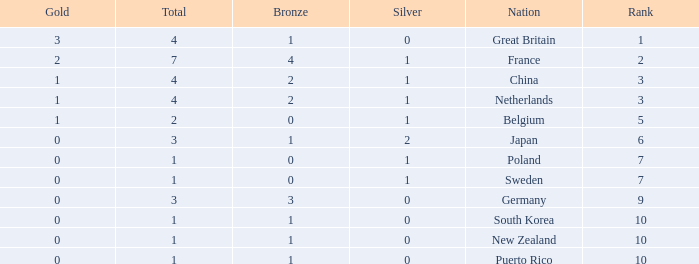What is the rank with 0 bronze? None. 